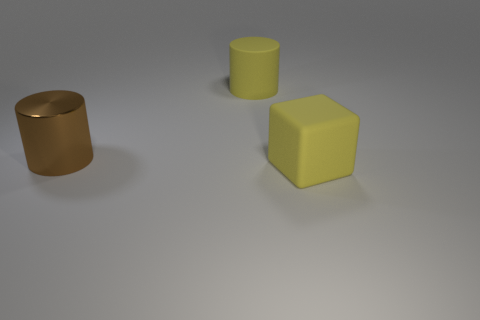Add 2 yellow cubes. How many objects exist? 5 Subtract all cylinders. How many objects are left? 1 Add 3 brown shiny cylinders. How many brown shiny cylinders exist? 4 Subtract 0 blue blocks. How many objects are left? 3 Subtract all small green rubber cubes. Subtract all yellow cylinders. How many objects are left? 2 Add 3 matte cylinders. How many matte cylinders are left? 4 